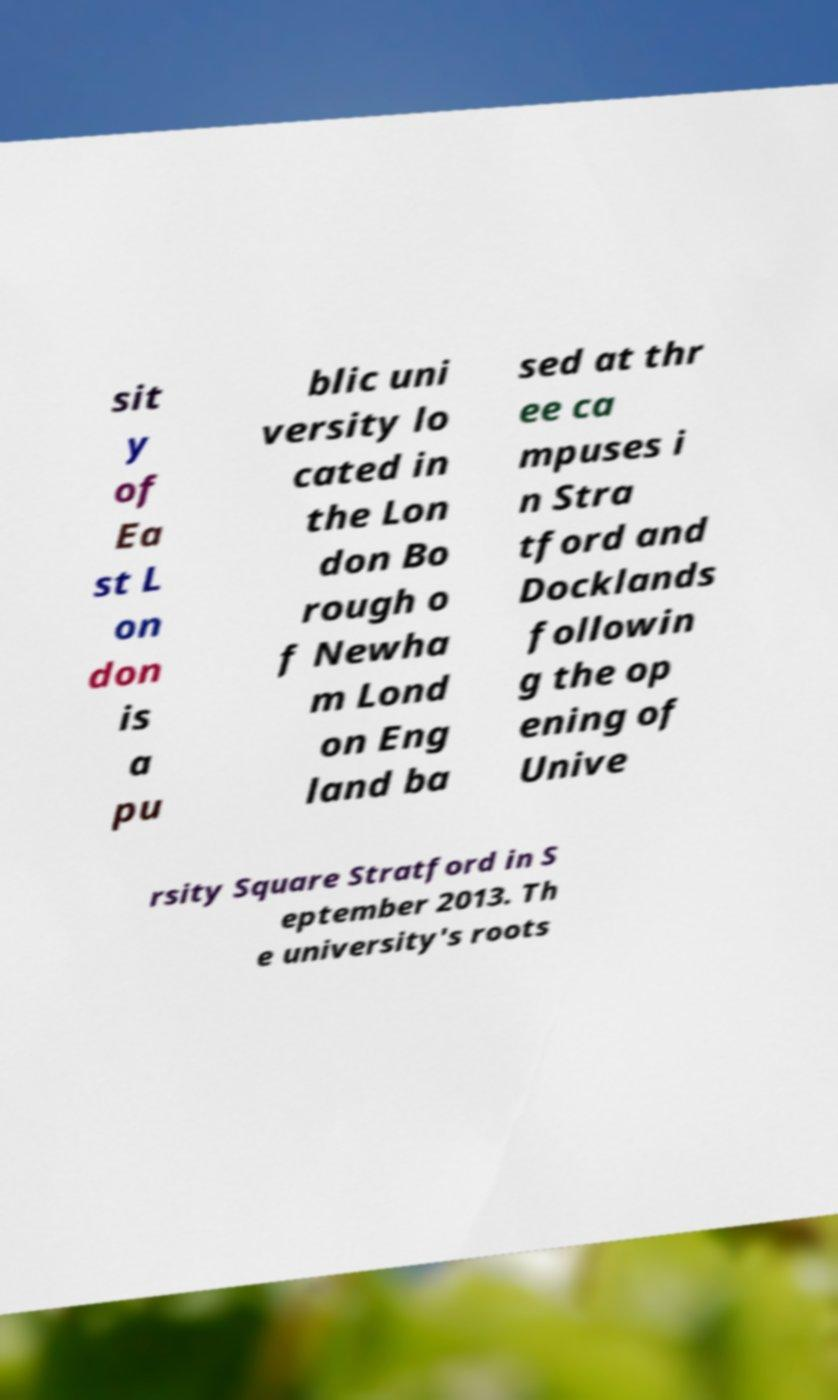I need the written content from this picture converted into text. Can you do that? sit y of Ea st L on don is a pu blic uni versity lo cated in the Lon don Bo rough o f Newha m Lond on Eng land ba sed at thr ee ca mpuses i n Stra tford and Docklands followin g the op ening of Unive rsity Square Stratford in S eptember 2013. Th e university's roots 